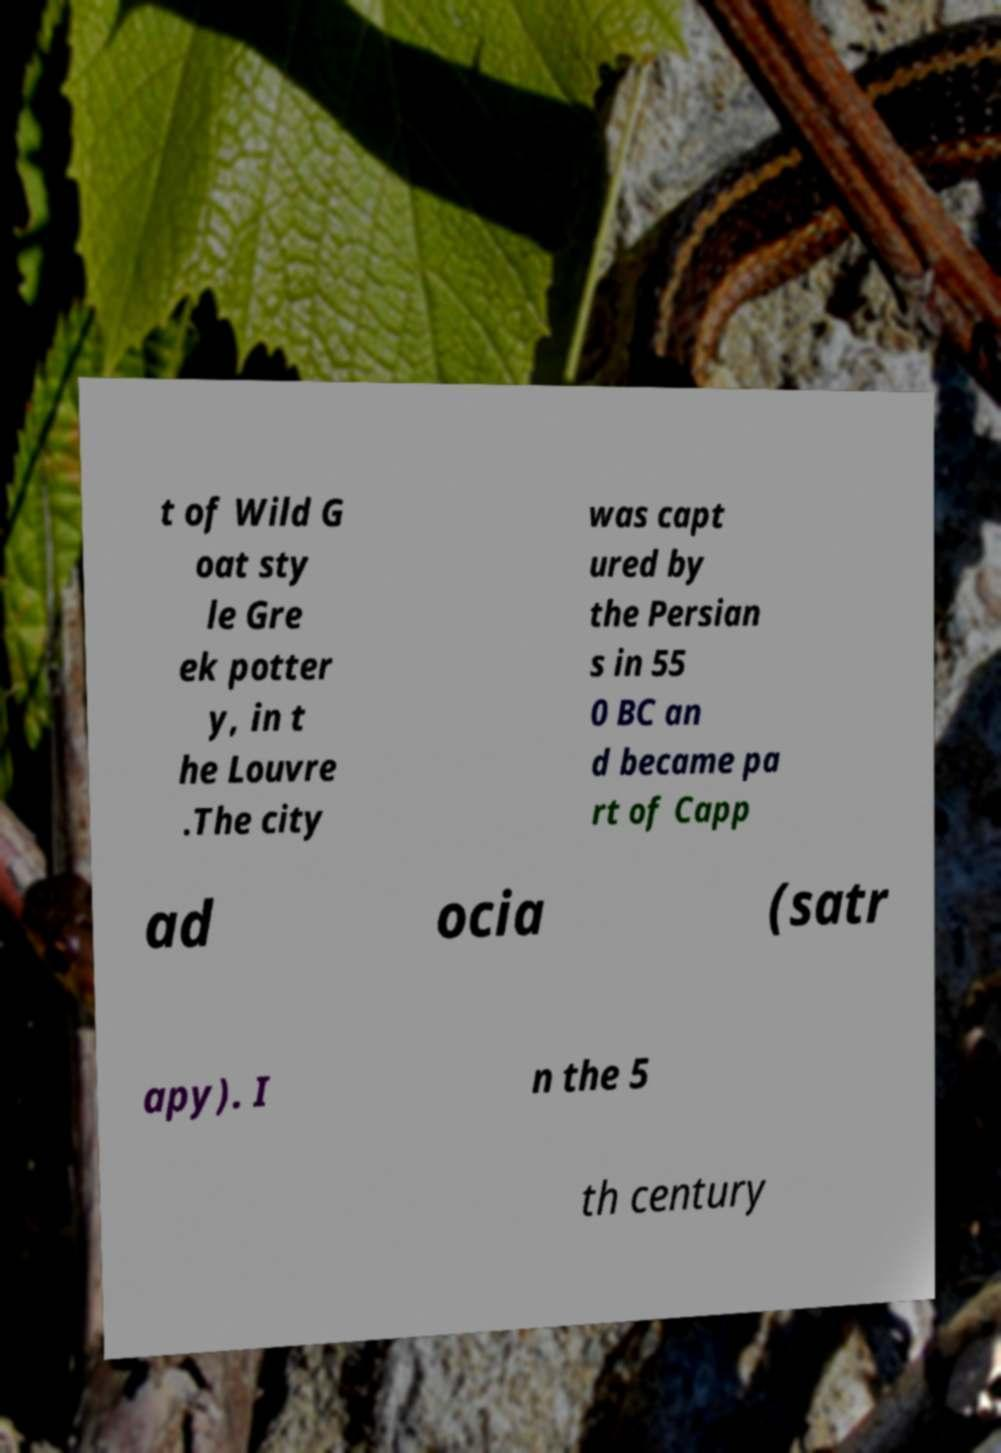Can you read and provide the text displayed in the image?This photo seems to have some interesting text. Can you extract and type it out for me? t of Wild G oat sty le Gre ek potter y, in t he Louvre .The city was capt ured by the Persian s in 55 0 BC an d became pa rt of Capp ad ocia (satr apy). I n the 5 th century 